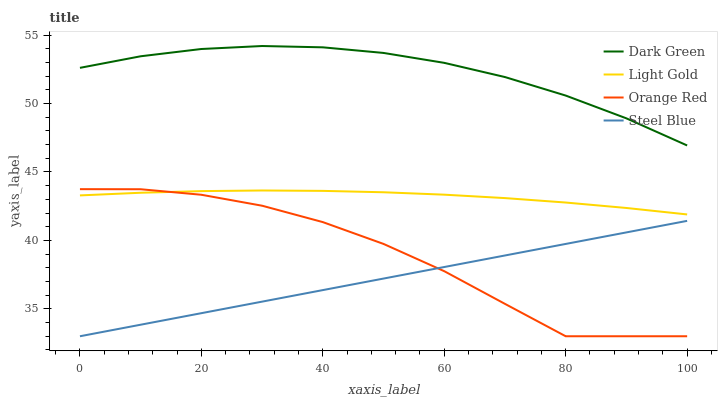Does Steel Blue have the minimum area under the curve?
Answer yes or no. Yes. Does Dark Green have the maximum area under the curve?
Answer yes or no. Yes. Does Light Gold have the minimum area under the curve?
Answer yes or no. No. Does Light Gold have the maximum area under the curve?
Answer yes or no. No. Is Steel Blue the smoothest?
Answer yes or no. Yes. Is Orange Red the roughest?
Answer yes or no. Yes. Is Light Gold the smoothest?
Answer yes or no. No. Is Light Gold the roughest?
Answer yes or no. No. Does Steel Blue have the lowest value?
Answer yes or no. Yes. Does Light Gold have the lowest value?
Answer yes or no. No. Does Dark Green have the highest value?
Answer yes or no. Yes. Does Light Gold have the highest value?
Answer yes or no. No. Is Steel Blue less than Light Gold?
Answer yes or no. Yes. Is Dark Green greater than Orange Red?
Answer yes or no. Yes. Does Orange Red intersect Steel Blue?
Answer yes or no. Yes. Is Orange Red less than Steel Blue?
Answer yes or no. No. Is Orange Red greater than Steel Blue?
Answer yes or no. No. Does Steel Blue intersect Light Gold?
Answer yes or no. No. 